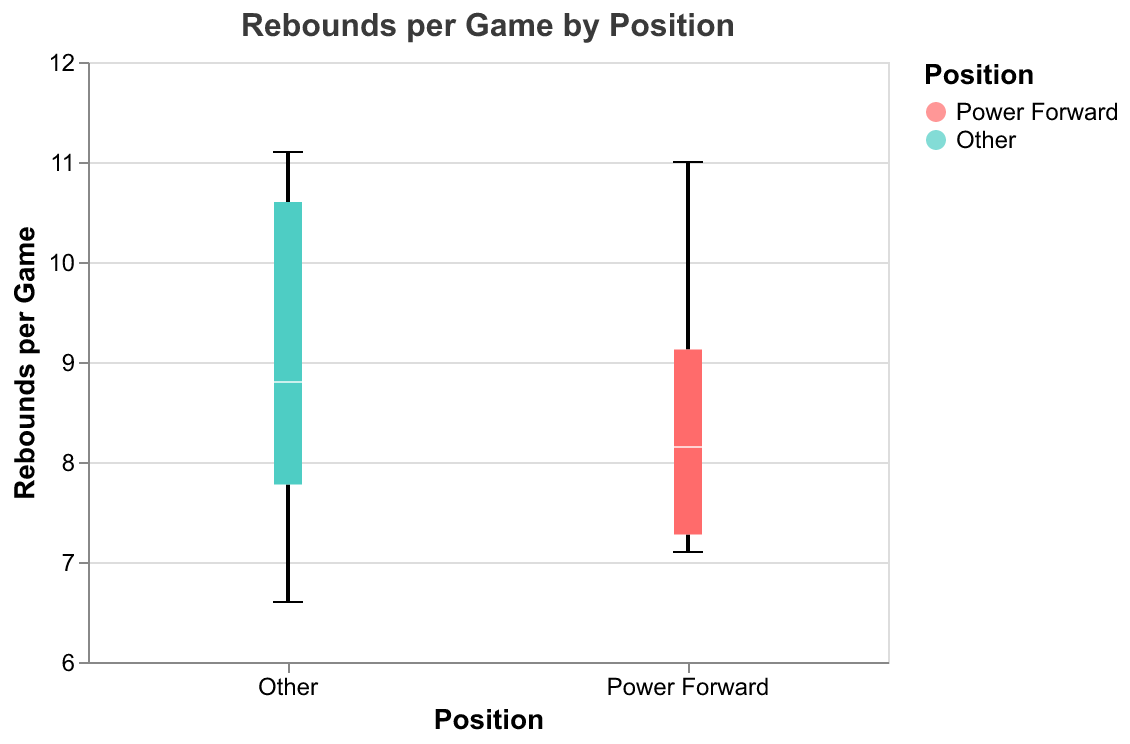What is the median rebounds per game for Power Forwards? The median is represented by a white line in a box plot. Identify the white line within the Power Forward's box.
Answer: 8.1 What is the maximum rebounds per game for positions other than Power Forward? In a box plot, the maximum value is indicated by the top whisker. Look at the highest point of the whisker for the "Other" category.
Answer: 11.1 Which position shows a wider interquartile range (IQR) for rebounds per game? Compare the lengths of the boxes for both positions, as the IQR is represented by the size of the box.
Answer: Other What is the range of rebounds per game for Power Forwards? The range is the difference between the maximum and minimum values. Identify the top and bottom whiskers for Power Forwards and subtract the smallest value from the largest.
Answer: 3.9 How many players are there from positions other than Power Forward? Count the number of data points within the "Other" category.
Answer: 8 Which position has a higher median rebounds per game? Compare the position of the white lines (medians) in both boxes visually to see which is higher.
Answer: Other What is the minimum rebounds per game recorded by Power Forwards? In a box plot, the minimum value is indicated by the bottom whisker. Look at the lowest point of the whisker for Power Forwards.
Answer: 7.1 What is the difference in range of rebounds per game between the two positions? Find the range for both positions by identifying their maximum and minimum points and subtracting the range of Power Forwards from the range of Other positions.
Answer: 1.1 Is there more variability in rebounds per game for players who are not Power Forwards? Variability can be inferred by the spread of the data points and length of the whiskers. Compare the length of the boxes and whiskers for both categories.
Answer: Yes 